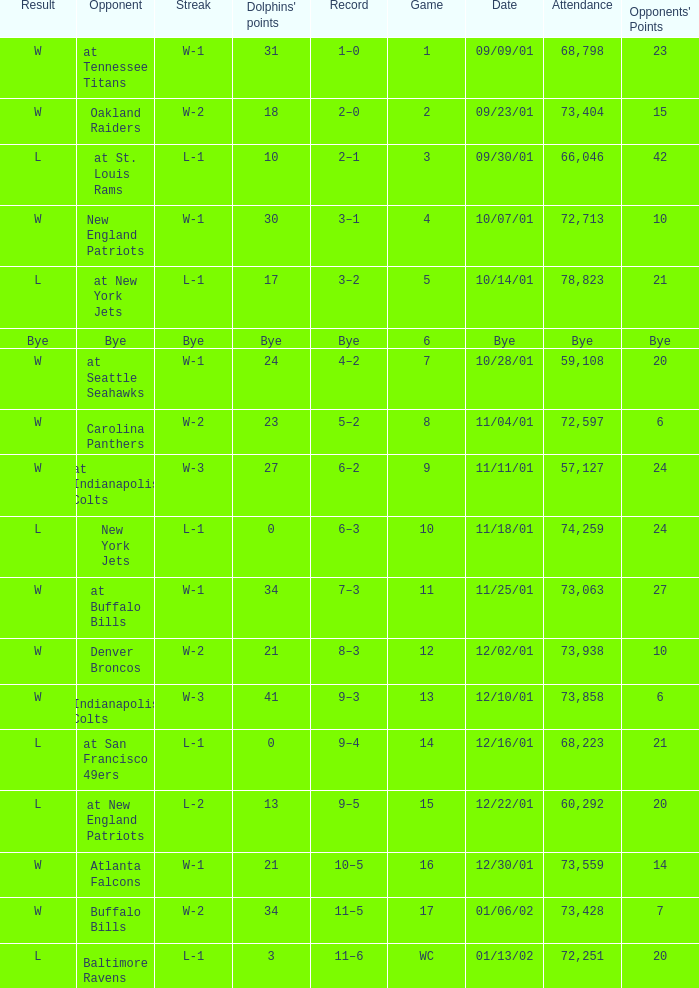What was the attendance of the Oakland Raiders game? 73404.0. 